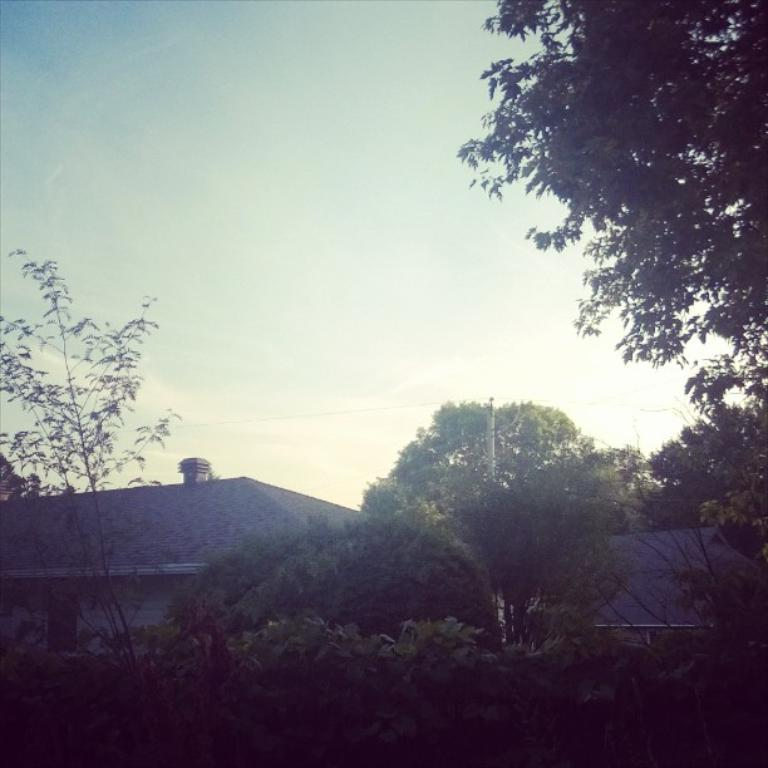What type of vegetation can be seen in the image? There are trees in the image. What type of structures are visible in the image? There are roofs of houses visible in the image. What can be seen in the sky in the image? Clouds are present in the sky in the image. What type of nerve can be seen in the image? There is no nerve present in the image; it features trees, roofs of houses, and clouds in the sky. Can you tell me how many pickles are visible in the image? There are no pickles present in the image. 